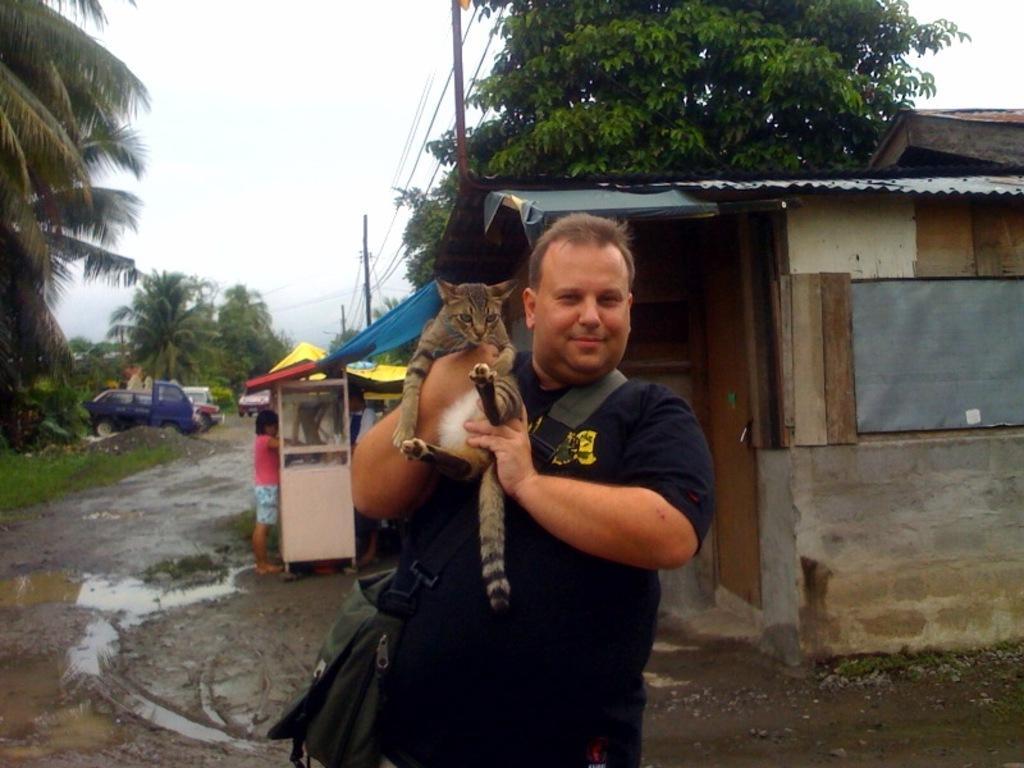Please provide a concise description of this image. In this picture we can see a man is holding a cat and standing on the path. Behind the man there is a kid, houses, some vehicles are parked on the path, trees, electric poles with cables and a sky. 